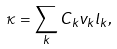Convert formula to latex. <formula><loc_0><loc_0><loc_500><loc_500>\kappa = \sum _ { k } { C _ { k } v _ { k } l _ { k } } ,</formula> 